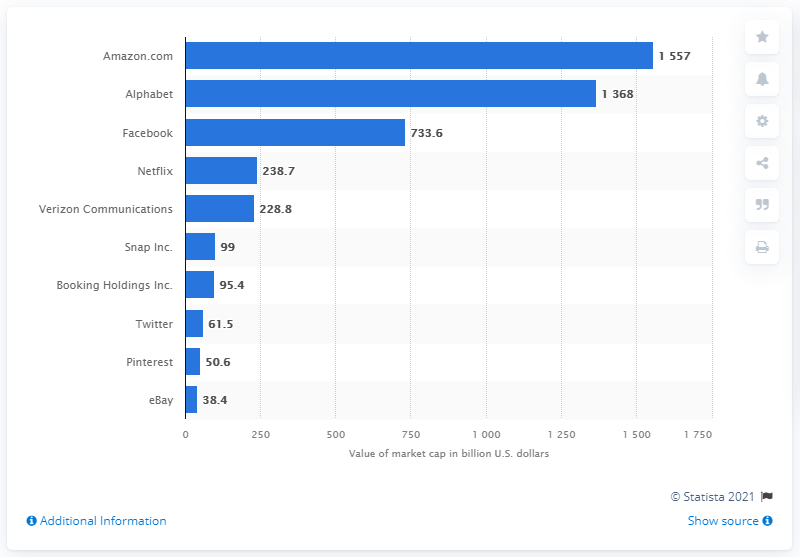Draw attention to some important aspects in this diagram. As of February 2021, Amazon had a market capitalization of approximately 1557. 